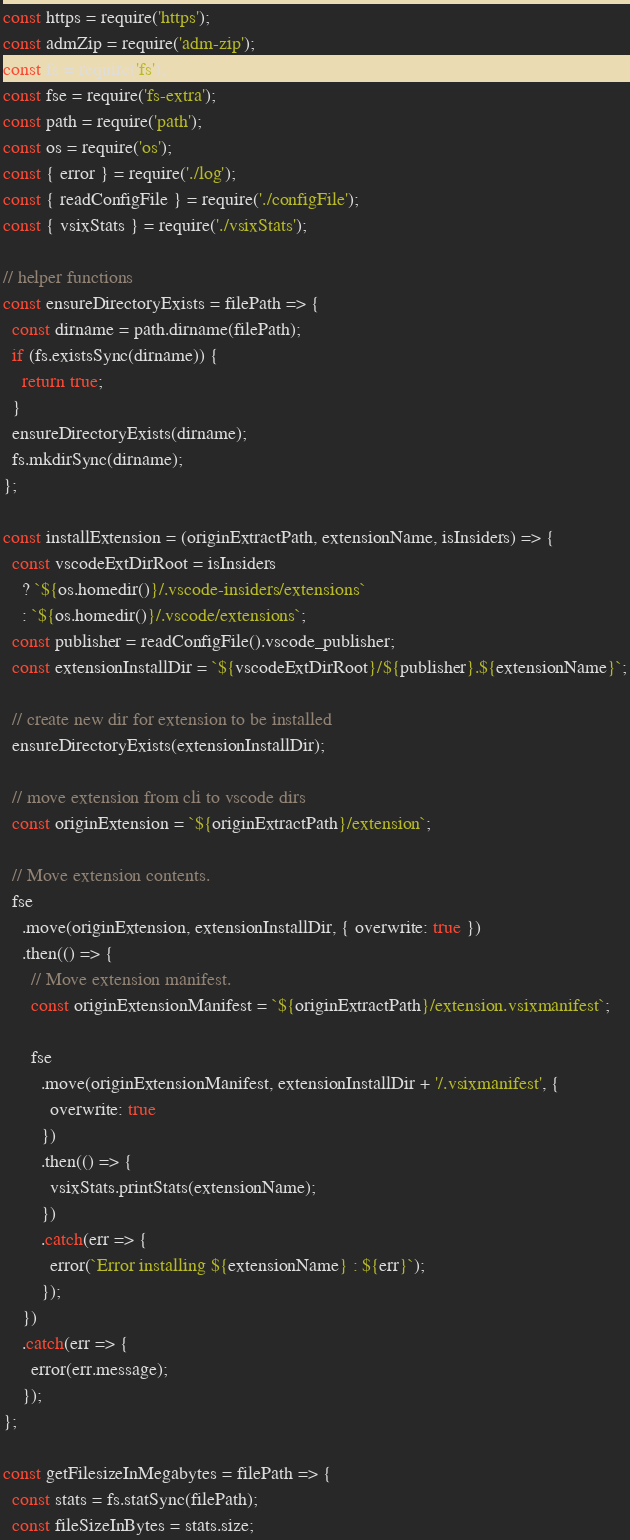Convert code to text. <code><loc_0><loc_0><loc_500><loc_500><_JavaScript_>const https = require('https');
const admZip = require('adm-zip');
const fs = require('fs');
const fse = require('fs-extra');
const path = require('path');
const os = require('os');
const { error } = require('./log');
const { readConfigFile } = require('./configFile');
const { vsixStats } = require('./vsixStats');

// helper functions
const ensureDirectoryExists = filePath => {
  const dirname = path.dirname(filePath);
  if (fs.existsSync(dirname)) {
    return true;
  }
  ensureDirectoryExists(dirname);
  fs.mkdirSync(dirname);
};

const installExtension = (originExtractPath, extensionName, isInsiders) => {
  const vscodeExtDirRoot = isInsiders
    ? `${os.homedir()}/.vscode-insiders/extensions`
    : `${os.homedir()}/.vscode/extensions`;
  const publisher = readConfigFile().vscode_publisher;
  const extensionInstallDir = `${vscodeExtDirRoot}/${publisher}.${extensionName}`;

  // create new dir for extension to be installed
  ensureDirectoryExists(extensionInstallDir);

  // move extension from cli to vscode dirs
  const originExtension = `${originExtractPath}/extension`;

  // Move extension contents.
  fse
    .move(originExtension, extensionInstallDir, { overwrite: true })
    .then(() => {
      // Move extension manifest.
      const originExtensionManifest = `${originExtractPath}/extension.vsixmanifest`;

      fse
        .move(originExtensionManifest, extensionInstallDir + '/.vsixmanifest', {
          overwrite: true
        })
        .then(() => {
          vsixStats.printStats(extensionName);
        })
        .catch(err => {
          error(`Error installing ${extensionName} : ${err}`);
        });
    })
    .catch(err => {
      error(err.message);
    });
};

const getFilesizeInMegabytes = filePath => {
  const stats = fs.statSync(filePath);
  const fileSizeInBytes = stats.size;</code> 